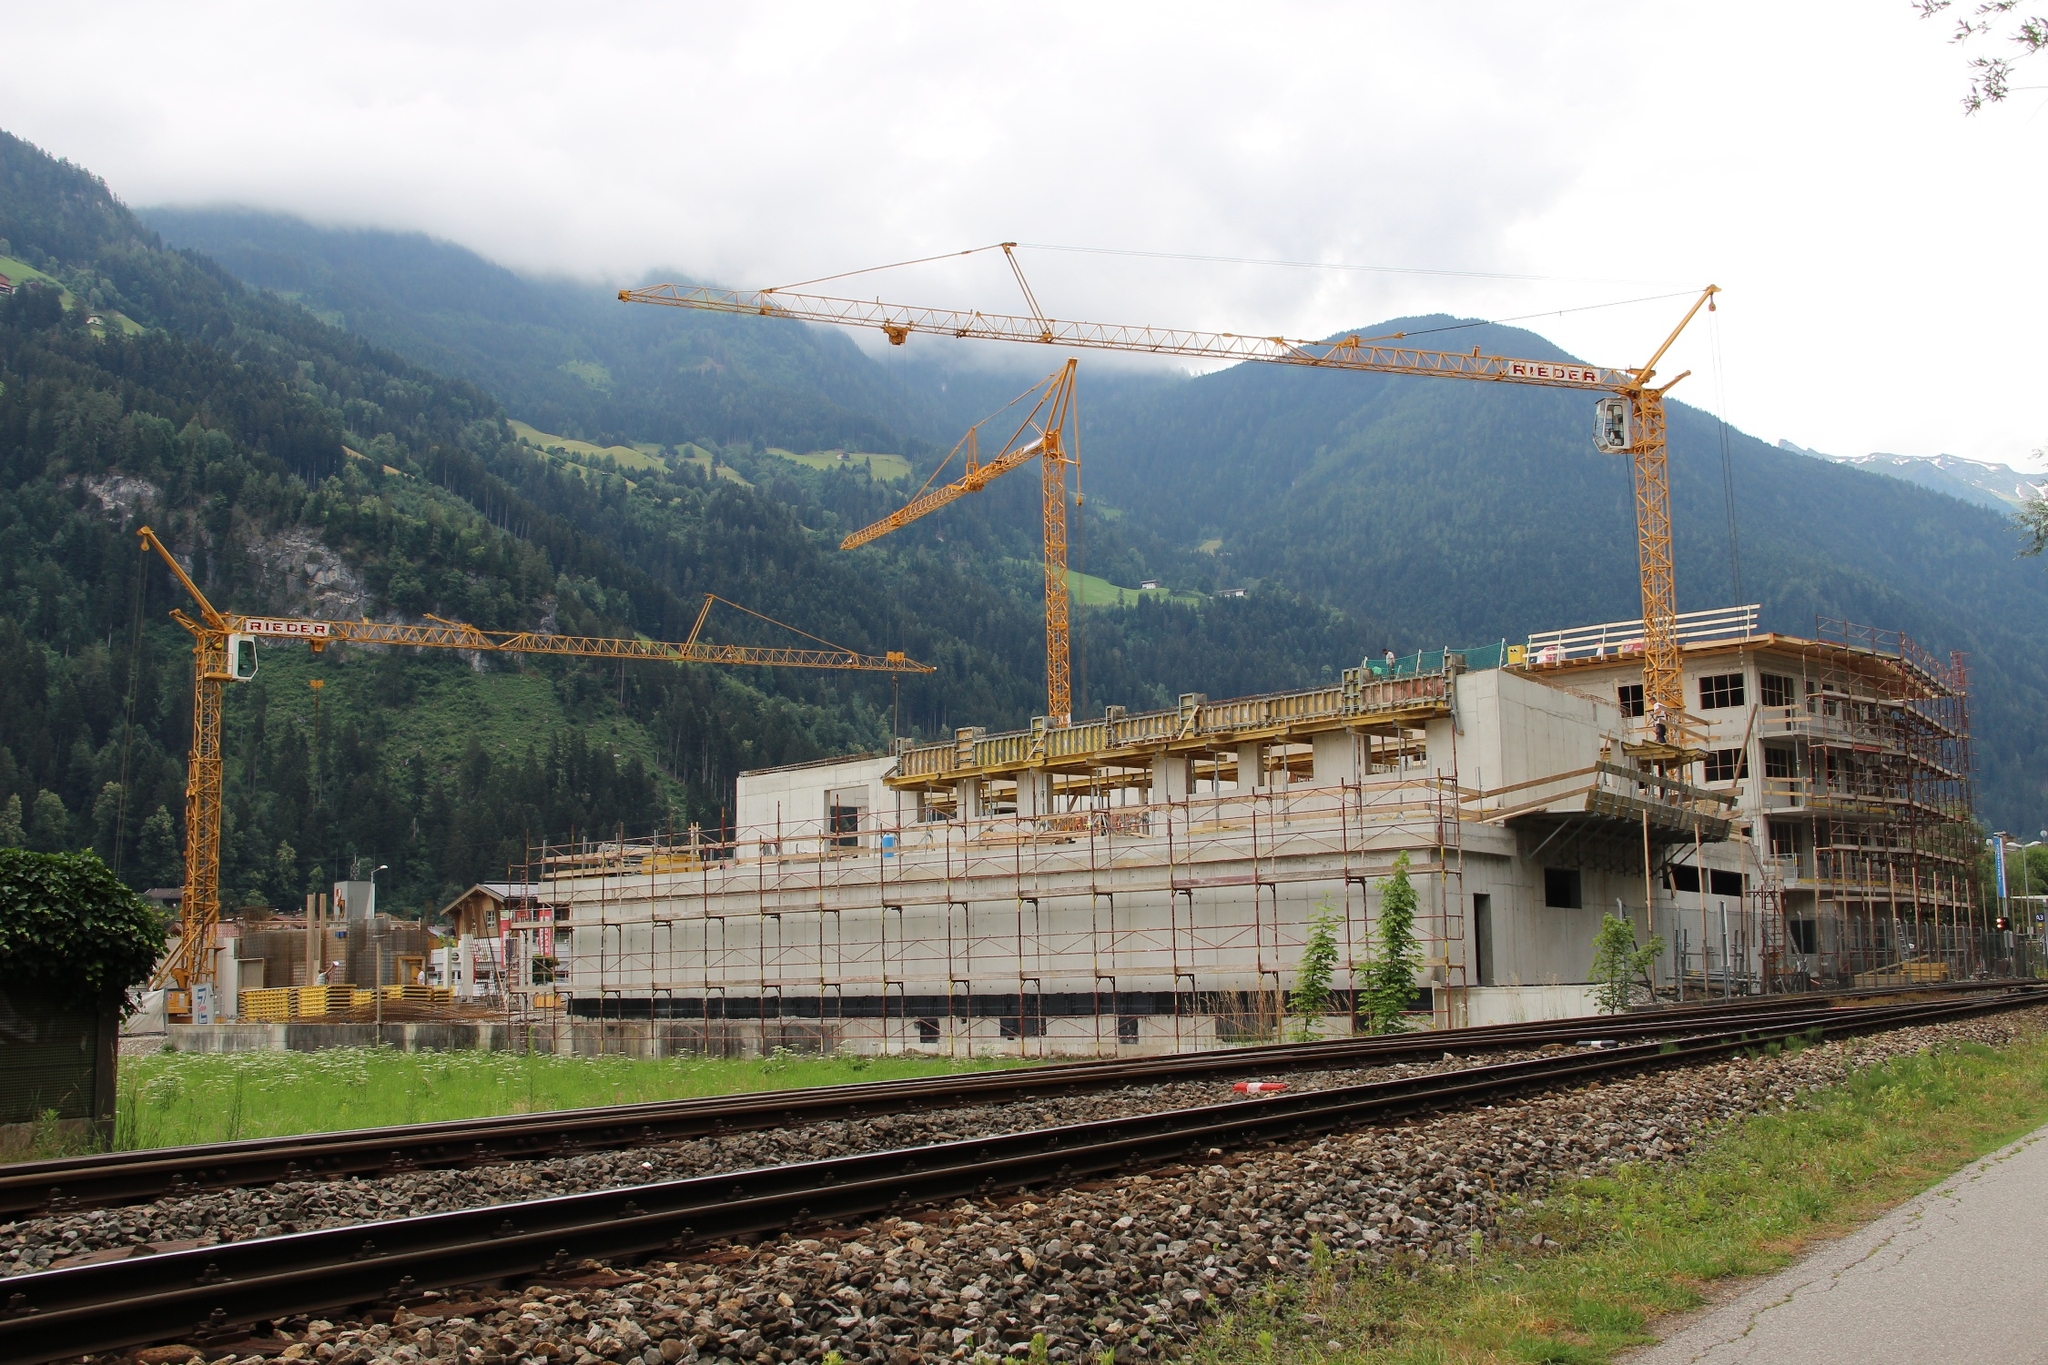Imagine this scene in a realistic scenario, where the site's purpose is revealed. Can you describe it in a long, detailed narrative? In the midst of the serene Alpine landscape, a groundbreaking construction project is underway—an eco-friendly resort that aims to blend luxury with sustainability. This ambitious undertaking stands as a testament to innovative engineering and environmental stewardship. The resort, once completed, will feature state-of-the-art accommodations that leverage renewable energy sources, ensuring minimal ecological footprint while providing unparalleled comfort for its guests.
As the cranes pivot and lift their hefty loads, placing beams and girders into precise locations, the skeleton of the resort begins to take form. Each window is positioned to maximize natural light and offer breathtaking views of the encompassing mountains, which stand tall and majestic under a sky often draped in wisps of cloud. The building materials are carefully chosen to harmonize with the natural surroundings, comprising reclaimed wood, stone, and glass.
Nearby, developers have meticulously planned a network of trails that weave through the forest, each path designed to guide visitors through untouched nature while preserving the habitat. Educational boards along these trails will explain the local flora and fauna, offering an immersive experience rooted in respect and appreciation for the environment.
The train track at the foreground of the image will serve as a key transport link, ensuring that visitors can access the resort without overwhelming the local ecosystem with automobile traffic. Regular trains will bring guests to this haven of tranquility from major cities, reducing the carbon footprint typically associated with travel.
In every aspect, the site will reflect thoughtful integration with nature, from the whisper of the wind through the trees to the gentle murmur of the nearby river, creating an oasis of rest and rejuvenation that will stand in harmony with the pristine Alpine setting. 